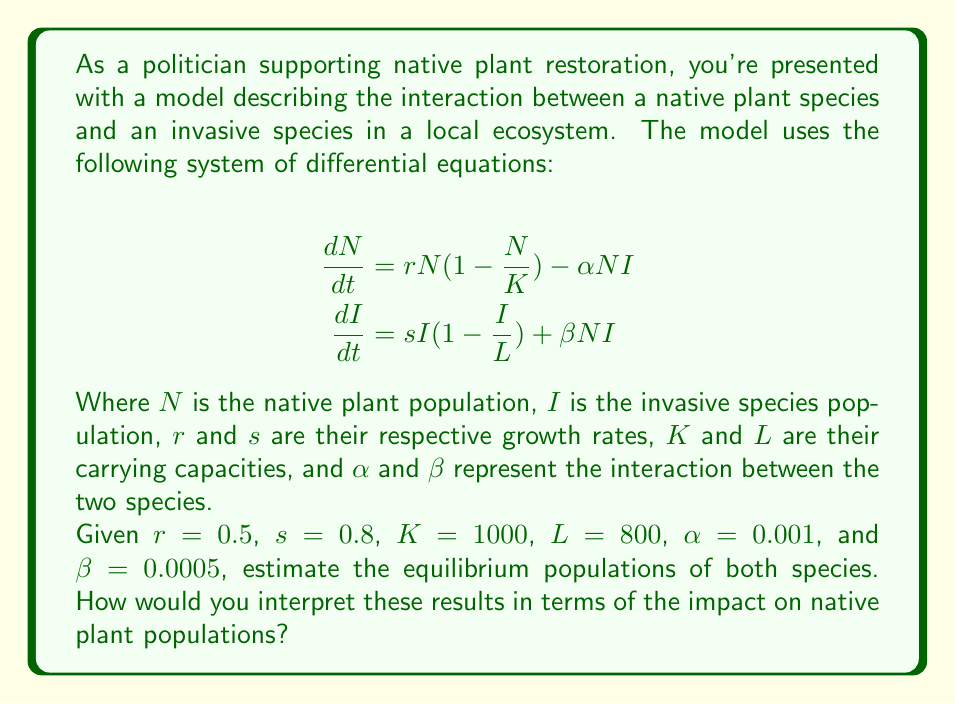Show me your answer to this math problem. To find the equilibrium populations, we need to set both equations equal to zero and solve for $N$ and $I$:

1) Set equations to zero:
   $$\begin{align}
   0 &= rN(1 - \frac{N}{K}) - \alpha NI \\
   0 &= sI(1 - \frac{I}{L}) + \beta NI
   \end{align}$$

2) From the first equation:
   $$rN(1 - \frac{N}{K}) = \alpha NI$$
   $$r(1 - \frac{N}{K}) = \alpha I$$
   $$r - \frac{rN}{K} = \alpha I$$
   $$r - \alpha I = \frac{rN}{K}$$
   $$N = \frac{K(r - \alpha I)}{r}$$

3) Substitute this into the second equation:
   $$0 = sI(1 - \frac{I}{L}) + \beta I \cdot \frac{K(r - \alpha I)}{r}$$

4) Expand and simplify:
   $$0 = sI - \frac{sI^2}{L} + \frac{\beta KI}{r} - \frac{\beta K\alpha I^2}{r}$$
   $$0 = I(s + \frac{\beta K}{r}) - I^2(\frac{s}{L} + \frac{\beta K\alpha}{r})$$

5) Factor out $I$:
   $$I[s + \frac{\beta K}{r} - I(\frac{s}{L} + \frac{\beta K\alpha}{r})] = 0$$

6) Solve for $I$:
   $$I = 0$$ or $$I = \frac{s + \frac{\beta K}{r}}{\frac{s}{L} + \frac{\beta K\alpha}{r}}$$

7) Substitute the given values:
   $$I = \frac{0.8 + \frac{0.0005 \cdot 1000}{0.5}}{\frac{0.8}{800} + \frac{0.0005 \cdot 1000 \cdot 0.001}{0.5}} \approx 754.72$$

8) Substitute this back into the equation for $N$:
   $$N = \frac{1000(0.5 - 0.001 \cdot 754.72)}{0.5} \approx 490.57$$

Interpretation: The equilibrium populations show that the invasive species has a significant impact on the native plant population. The native plant population ($N \approx 491$) is less than half of its carrying capacity ($K = 1000$), while the invasive species population ($I \approx 755$) is close to its carrying capacity ($L = 800$). This indicates that the invasive species is outcompeting the native plants, potentially leading to a long-term decline in native plant diversity and abundance.
Answer: Native plant equilibrium: 491; Invasive species equilibrium: 755. Significant negative impact on native plants. 